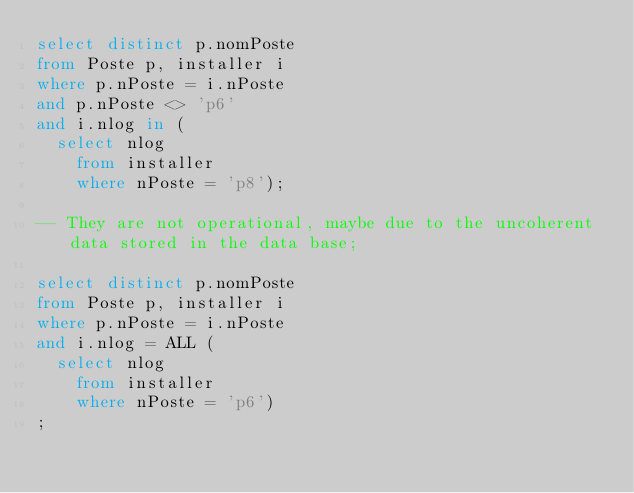<code> <loc_0><loc_0><loc_500><loc_500><_SQL_>select distinct p.nomPoste
from Poste p, installer i
where p.nPoste = i.nPoste
and p.nPoste <> 'p6'
and i.nlog in (
	select nlog 
    from installer
    where nPoste = 'p8'); 

-- They are not operational, maybe due to the uncoherent data stored in the data base; 

select distinct p.nomPoste
from Poste p, installer i
where p.nPoste = i.nPoste
and i.nlog = ALL (
	select nlog 
    from installer
    where nPoste = 'p6')
; </code> 